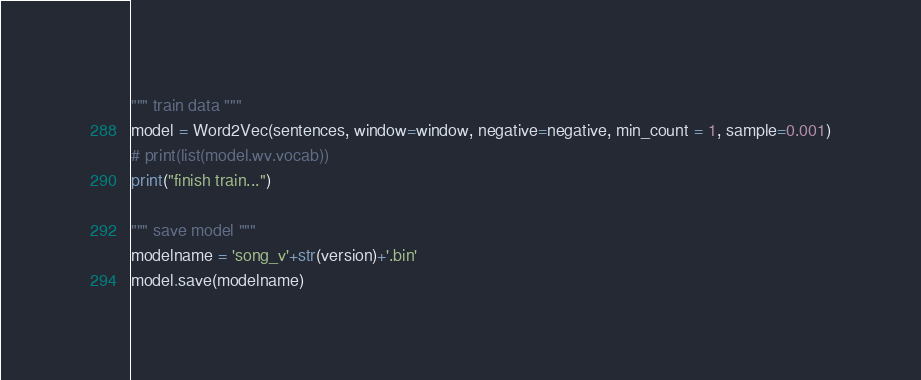Convert code to text. <code><loc_0><loc_0><loc_500><loc_500><_Python_>
""" train data """
model = Word2Vec(sentences, window=window, negative=negative, min_count = 1, sample=0.001)
# print(list(model.wv.vocab))
print("finish train...")

""" save model """
modelname = 'song_v'+str(version)+'.bin'
model.save(modelname)
</code> 